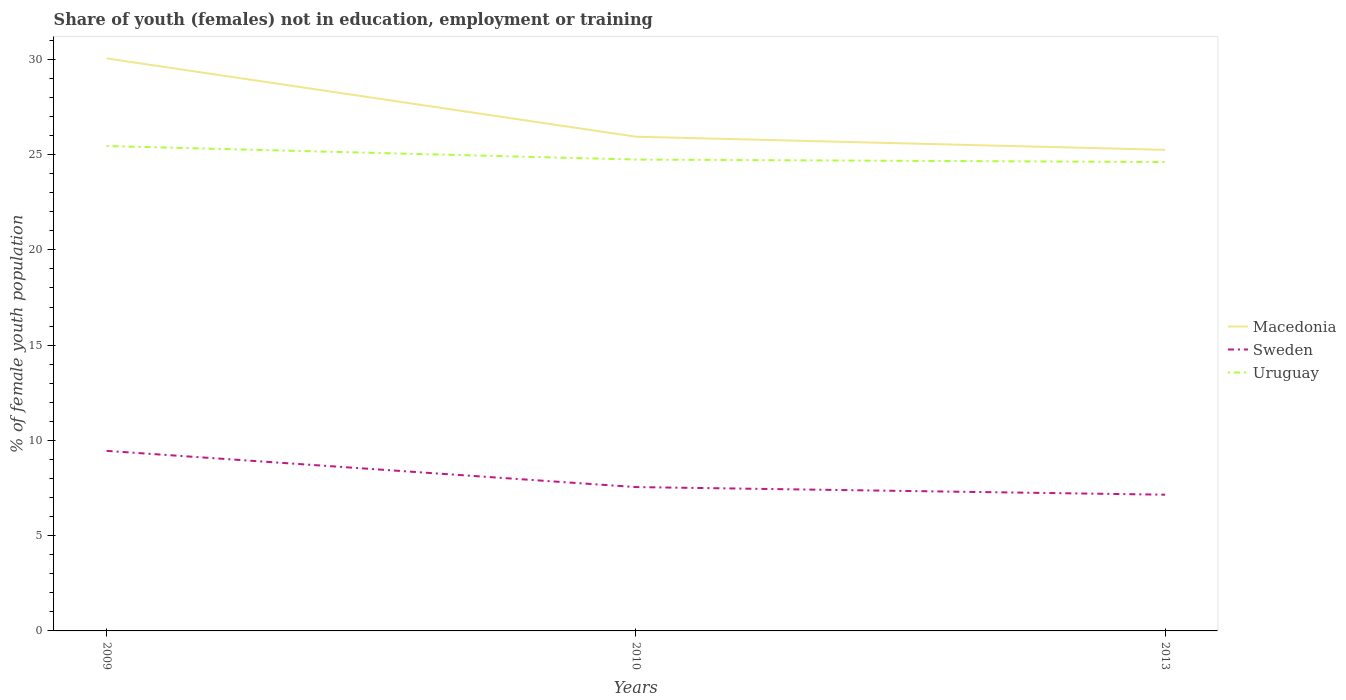Does the line corresponding to Sweden intersect with the line corresponding to Macedonia?
Your answer should be compact. No. Is the number of lines equal to the number of legend labels?
Provide a succinct answer. Yes. Across all years, what is the maximum percentage of unemployed female population in in Uruguay?
Ensure brevity in your answer.  24.61. In which year was the percentage of unemployed female population in in Uruguay maximum?
Offer a very short reply. 2013. What is the total percentage of unemployed female population in in Sweden in the graph?
Offer a very short reply. 2.3. What is the difference between the highest and the second highest percentage of unemployed female population in in Uruguay?
Your response must be concise. 0.84. How many lines are there?
Make the answer very short. 3. Where does the legend appear in the graph?
Ensure brevity in your answer.  Center right. What is the title of the graph?
Keep it short and to the point. Share of youth (females) not in education, employment or training. Does "Russian Federation" appear as one of the legend labels in the graph?
Your answer should be very brief. No. What is the label or title of the Y-axis?
Make the answer very short. % of female youth population. What is the % of female youth population of Macedonia in 2009?
Your answer should be very brief. 30.05. What is the % of female youth population in Sweden in 2009?
Your response must be concise. 9.45. What is the % of female youth population in Uruguay in 2009?
Give a very brief answer. 25.45. What is the % of female youth population of Macedonia in 2010?
Provide a short and direct response. 25.94. What is the % of female youth population in Sweden in 2010?
Provide a short and direct response. 7.55. What is the % of female youth population in Uruguay in 2010?
Keep it short and to the point. 24.74. What is the % of female youth population in Macedonia in 2013?
Your answer should be very brief. 25.25. What is the % of female youth population of Sweden in 2013?
Your response must be concise. 7.15. What is the % of female youth population of Uruguay in 2013?
Ensure brevity in your answer.  24.61. Across all years, what is the maximum % of female youth population in Macedonia?
Ensure brevity in your answer.  30.05. Across all years, what is the maximum % of female youth population in Sweden?
Your response must be concise. 9.45. Across all years, what is the maximum % of female youth population of Uruguay?
Offer a terse response. 25.45. Across all years, what is the minimum % of female youth population of Macedonia?
Ensure brevity in your answer.  25.25. Across all years, what is the minimum % of female youth population of Sweden?
Ensure brevity in your answer.  7.15. Across all years, what is the minimum % of female youth population of Uruguay?
Your answer should be very brief. 24.61. What is the total % of female youth population in Macedonia in the graph?
Provide a short and direct response. 81.24. What is the total % of female youth population of Sweden in the graph?
Ensure brevity in your answer.  24.15. What is the total % of female youth population of Uruguay in the graph?
Your response must be concise. 74.8. What is the difference between the % of female youth population in Macedonia in 2009 and that in 2010?
Ensure brevity in your answer.  4.11. What is the difference between the % of female youth population in Uruguay in 2009 and that in 2010?
Your answer should be compact. 0.71. What is the difference between the % of female youth population of Uruguay in 2009 and that in 2013?
Provide a succinct answer. 0.84. What is the difference between the % of female youth population of Macedonia in 2010 and that in 2013?
Provide a succinct answer. 0.69. What is the difference between the % of female youth population of Uruguay in 2010 and that in 2013?
Provide a short and direct response. 0.13. What is the difference between the % of female youth population in Macedonia in 2009 and the % of female youth population in Uruguay in 2010?
Your response must be concise. 5.31. What is the difference between the % of female youth population of Sweden in 2009 and the % of female youth population of Uruguay in 2010?
Keep it short and to the point. -15.29. What is the difference between the % of female youth population of Macedonia in 2009 and the % of female youth population of Sweden in 2013?
Give a very brief answer. 22.9. What is the difference between the % of female youth population in Macedonia in 2009 and the % of female youth population in Uruguay in 2013?
Offer a terse response. 5.44. What is the difference between the % of female youth population of Sweden in 2009 and the % of female youth population of Uruguay in 2013?
Your answer should be compact. -15.16. What is the difference between the % of female youth population in Macedonia in 2010 and the % of female youth population in Sweden in 2013?
Ensure brevity in your answer.  18.79. What is the difference between the % of female youth population of Macedonia in 2010 and the % of female youth population of Uruguay in 2013?
Offer a very short reply. 1.33. What is the difference between the % of female youth population in Sweden in 2010 and the % of female youth population in Uruguay in 2013?
Your answer should be very brief. -17.06. What is the average % of female youth population in Macedonia per year?
Offer a terse response. 27.08. What is the average % of female youth population in Sweden per year?
Give a very brief answer. 8.05. What is the average % of female youth population in Uruguay per year?
Provide a succinct answer. 24.93. In the year 2009, what is the difference between the % of female youth population of Macedonia and % of female youth population of Sweden?
Ensure brevity in your answer.  20.6. In the year 2009, what is the difference between the % of female youth population in Macedonia and % of female youth population in Uruguay?
Offer a very short reply. 4.6. In the year 2009, what is the difference between the % of female youth population in Sweden and % of female youth population in Uruguay?
Make the answer very short. -16. In the year 2010, what is the difference between the % of female youth population of Macedonia and % of female youth population of Sweden?
Give a very brief answer. 18.39. In the year 2010, what is the difference between the % of female youth population in Macedonia and % of female youth population in Uruguay?
Your response must be concise. 1.2. In the year 2010, what is the difference between the % of female youth population in Sweden and % of female youth population in Uruguay?
Provide a succinct answer. -17.19. In the year 2013, what is the difference between the % of female youth population of Macedonia and % of female youth population of Uruguay?
Offer a terse response. 0.64. In the year 2013, what is the difference between the % of female youth population in Sweden and % of female youth population in Uruguay?
Offer a terse response. -17.46. What is the ratio of the % of female youth population of Macedonia in 2009 to that in 2010?
Ensure brevity in your answer.  1.16. What is the ratio of the % of female youth population in Sweden in 2009 to that in 2010?
Provide a succinct answer. 1.25. What is the ratio of the % of female youth population of Uruguay in 2009 to that in 2010?
Provide a succinct answer. 1.03. What is the ratio of the % of female youth population in Macedonia in 2009 to that in 2013?
Offer a terse response. 1.19. What is the ratio of the % of female youth population in Sweden in 2009 to that in 2013?
Provide a succinct answer. 1.32. What is the ratio of the % of female youth population in Uruguay in 2009 to that in 2013?
Give a very brief answer. 1.03. What is the ratio of the % of female youth population of Macedonia in 2010 to that in 2013?
Offer a very short reply. 1.03. What is the ratio of the % of female youth population of Sweden in 2010 to that in 2013?
Provide a succinct answer. 1.06. What is the difference between the highest and the second highest % of female youth population of Macedonia?
Provide a succinct answer. 4.11. What is the difference between the highest and the second highest % of female youth population in Sweden?
Give a very brief answer. 1.9. What is the difference between the highest and the second highest % of female youth population in Uruguay?
Keep it short and to the point. 0.71. What is the difference between the highest and the lowest % of female youth population in Sweden?
Make the answer very short. 2.3. What is the difference between the highest and the lowest % of female youth population of Uruguay?
Keep it short and to the point. 0.84. 